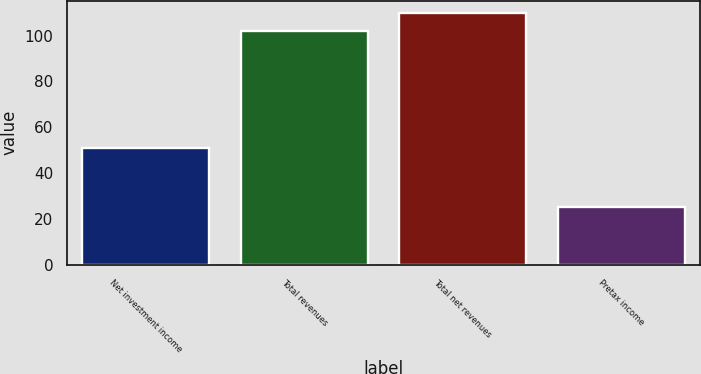<chart> <loc_0><loc_0><loc_500><loc_500><bar_chart><fcel>Net investment income<fcel>Total revenues<fcel>Total net revenues<fcel>Pretax income<nl><fcel>51<fcel>102<fcel>109.7<fcel>25<nl></chart> 